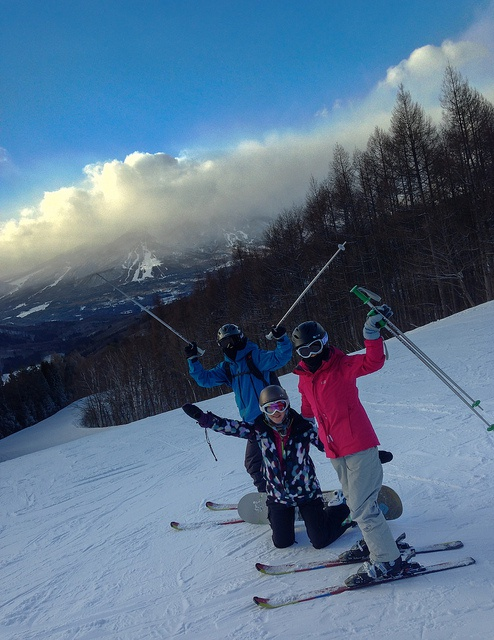Describe the objects in this image and their specific colors. I can see people in teal, purple, gray, black, and brown tones, people in teal, black, navy, and gray tones, people in teal, navy, black, and blue tones, skis in teal, gray, and darkgray tones, and snowboard in teal, gray, navy, and blue tones in this image. 